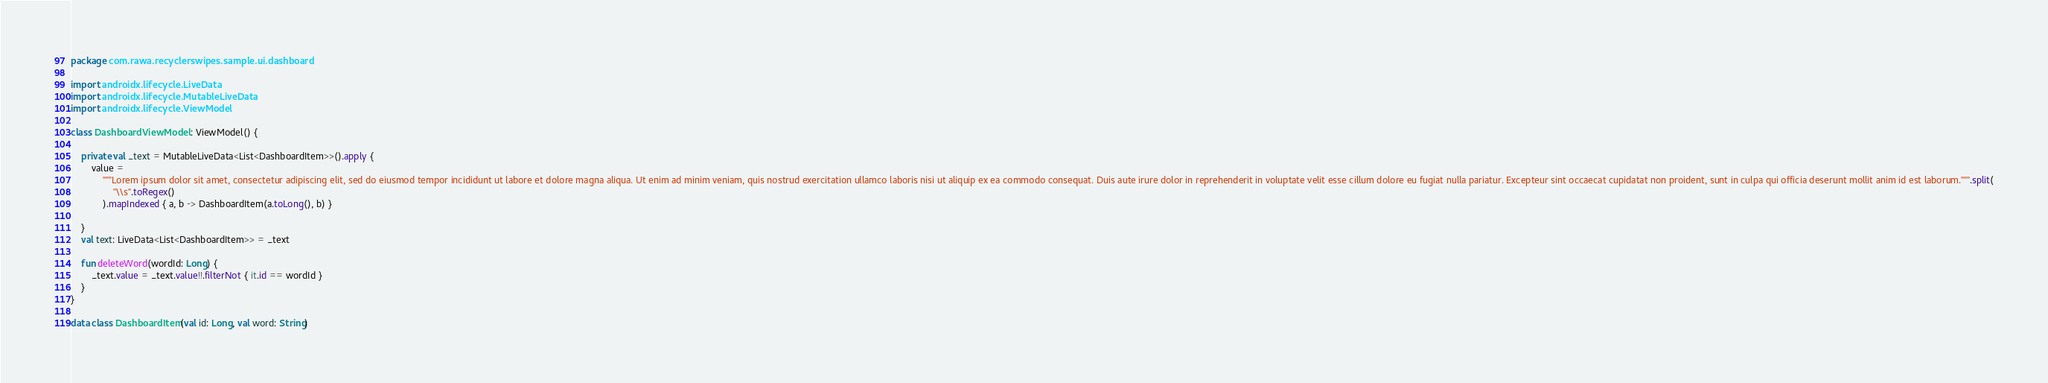<code> <loc_0><loc_0><loc_500><loc_500><_Kotlin_>package com.rawa.recyclerswipes.sample.ui.dashboard

import androidx.lifecycle.LiveData
import androidx.lifecycle.MutableLiveData
import androidx.lifecycle.ViewModel

class DashboardViewModel : ViewModel() {

    private val _text = MutableLiveData<List<DashboardItem>>().apply {
        value =
            """Lorem ipsum dolor sit amet, consectetur adipiscing elit, sed do eiusmod tempor incididunt ut labore et dolore magna aliqua. Ut enim ad minim veniam, quis nostrud exercitation ullamco laboris nisi ut aliquip ex ea commodo consequat. Duis aute irure dolor in reprehenderit in voluptate velit esse cillum dolore eu fugiat nulla pariatur. Excepteur sint occaecat cupidatat non proident, sunt in culpa qui officia deserunt mollit anim id est laborum.""".split(
                "\\s".toRegex()
            ).mapIndexed { a, b -> DashboardItem(a.toLong(), b) }

    }
    val text: LiveData<List<DashboardItem>> = _text

    fun deleteWord(wordId: Long) {
        _text.value = _text.value!!.filterNot { it.id == wordId }
    }
}

data class DashboardItem(val id: Long, val word: String)
</code> 